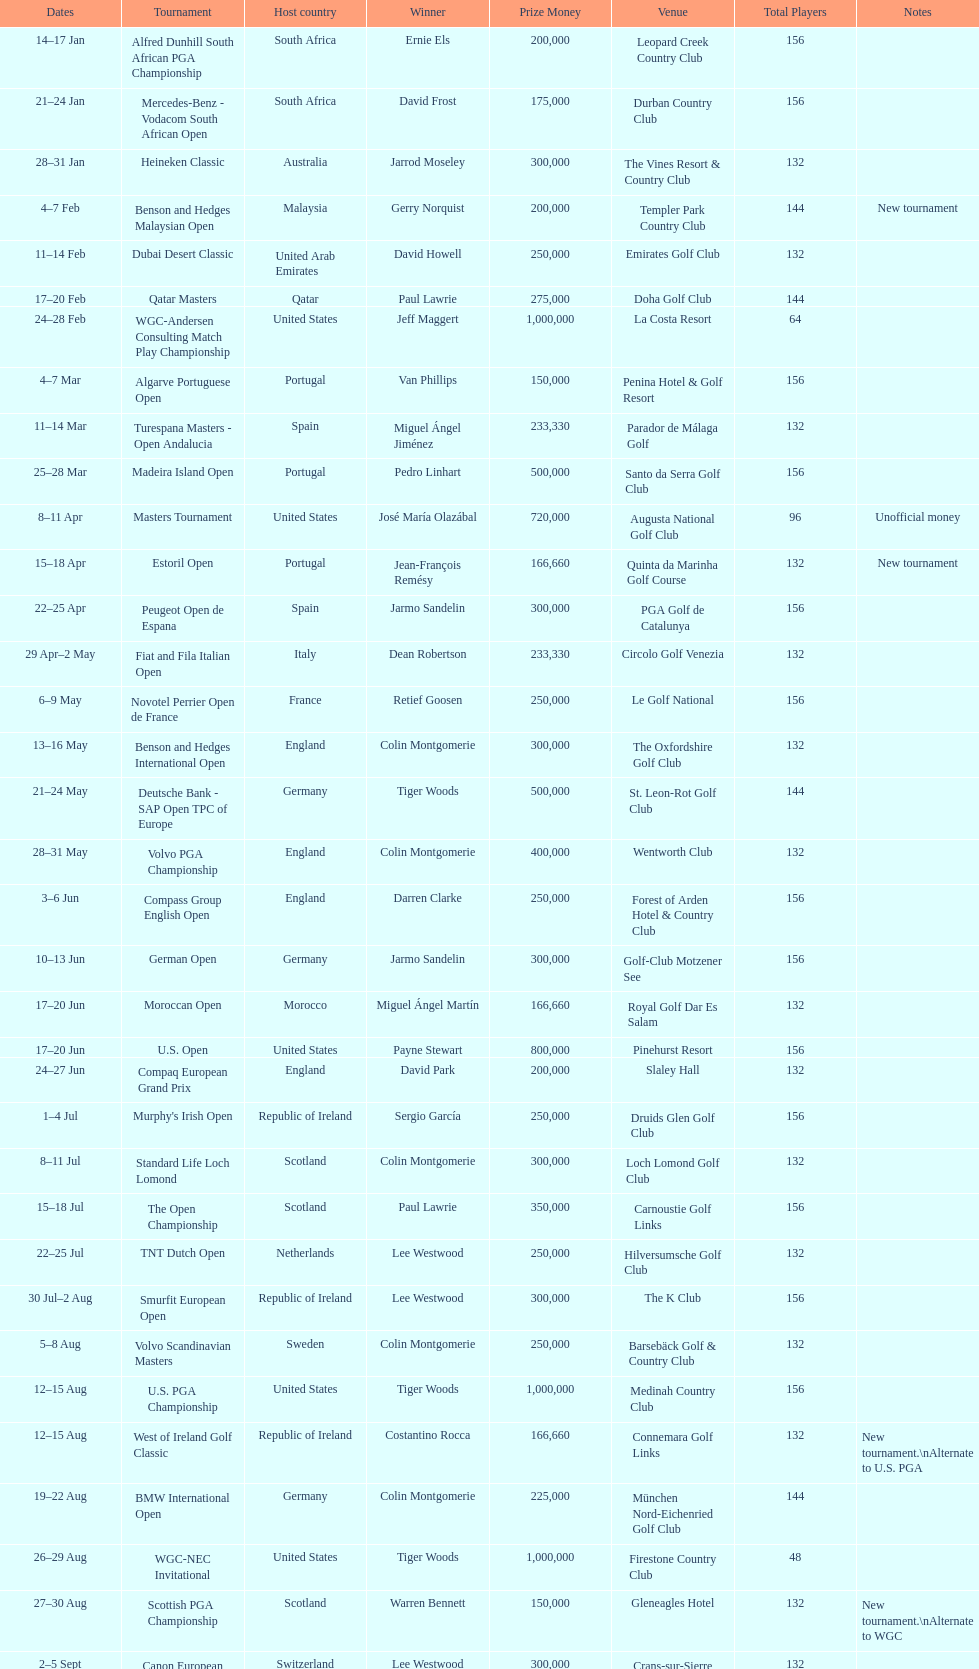How long did the estoril open last? 3 days. 